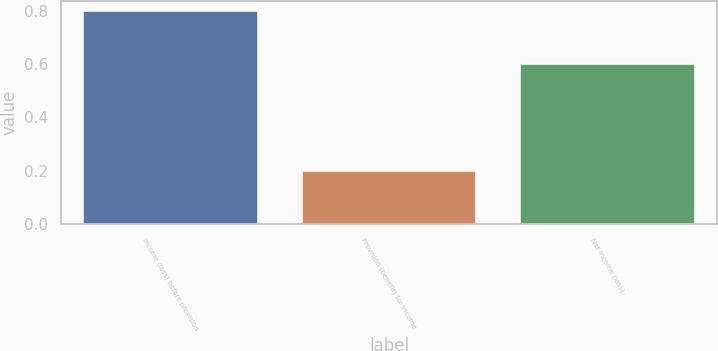Convert chart. <chart><loc_0><loc_0><loc_500><loc_500><bar_chart><fcel>Income (loss) before provision<fcel>Provision (benefit) for income<fcel>Net income (loss)<nl><fcel>0.8<fcel>0.2<fcel>0.6<nl></chart> 